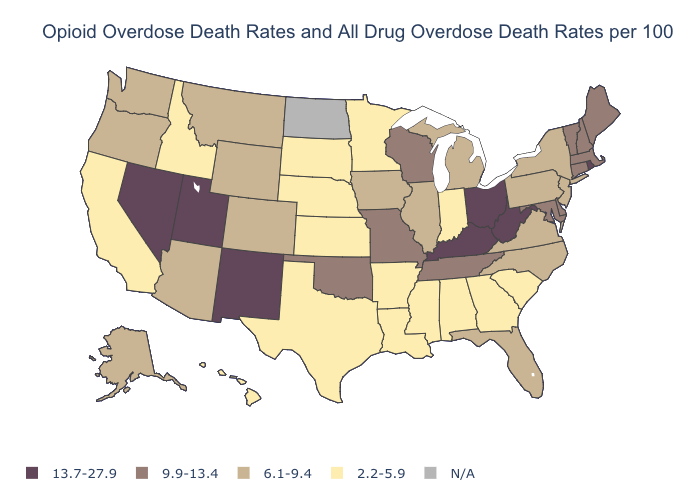What is the highest value in states that border Arkansas?
Be succinct. 9.9-13.4. Among the states that border Massachusetts , which have the highest value?
Give a very brief answer. Rhode Island. What is the highest value in states that border Illinois?
Write a very short answer. 13.7-27.9. What is the value of Pennsylvania?
Answer briefly. 6.1-9.4. Among the states that border Washington , which have the lowest value?
Quick response, please. Idaho. What is the highest value in the Northeast ?
Be succinct. 13.7-27.9. What is the value of Delaware?
Write a very short answer. 9.9-13.4. What is the value of Louisiana?
Write a very short answer. 2.2-5.9. How many symbols are there in the legend?
Give a very brief answer. 5. How many symbols are there in the legend?
Give a very brief answer. 5. What is the value of Maine?
Quick response, please. 9.9-13.4. Among the states that border New York , which have the lowest value?
Quick response, please. New Jersey, Pennsylvania. Name the states that have a value in the range N/A?
Keep it brief. North Dakota. What is the value of South Dakota?
Be succinct. 2.2-5.9. 